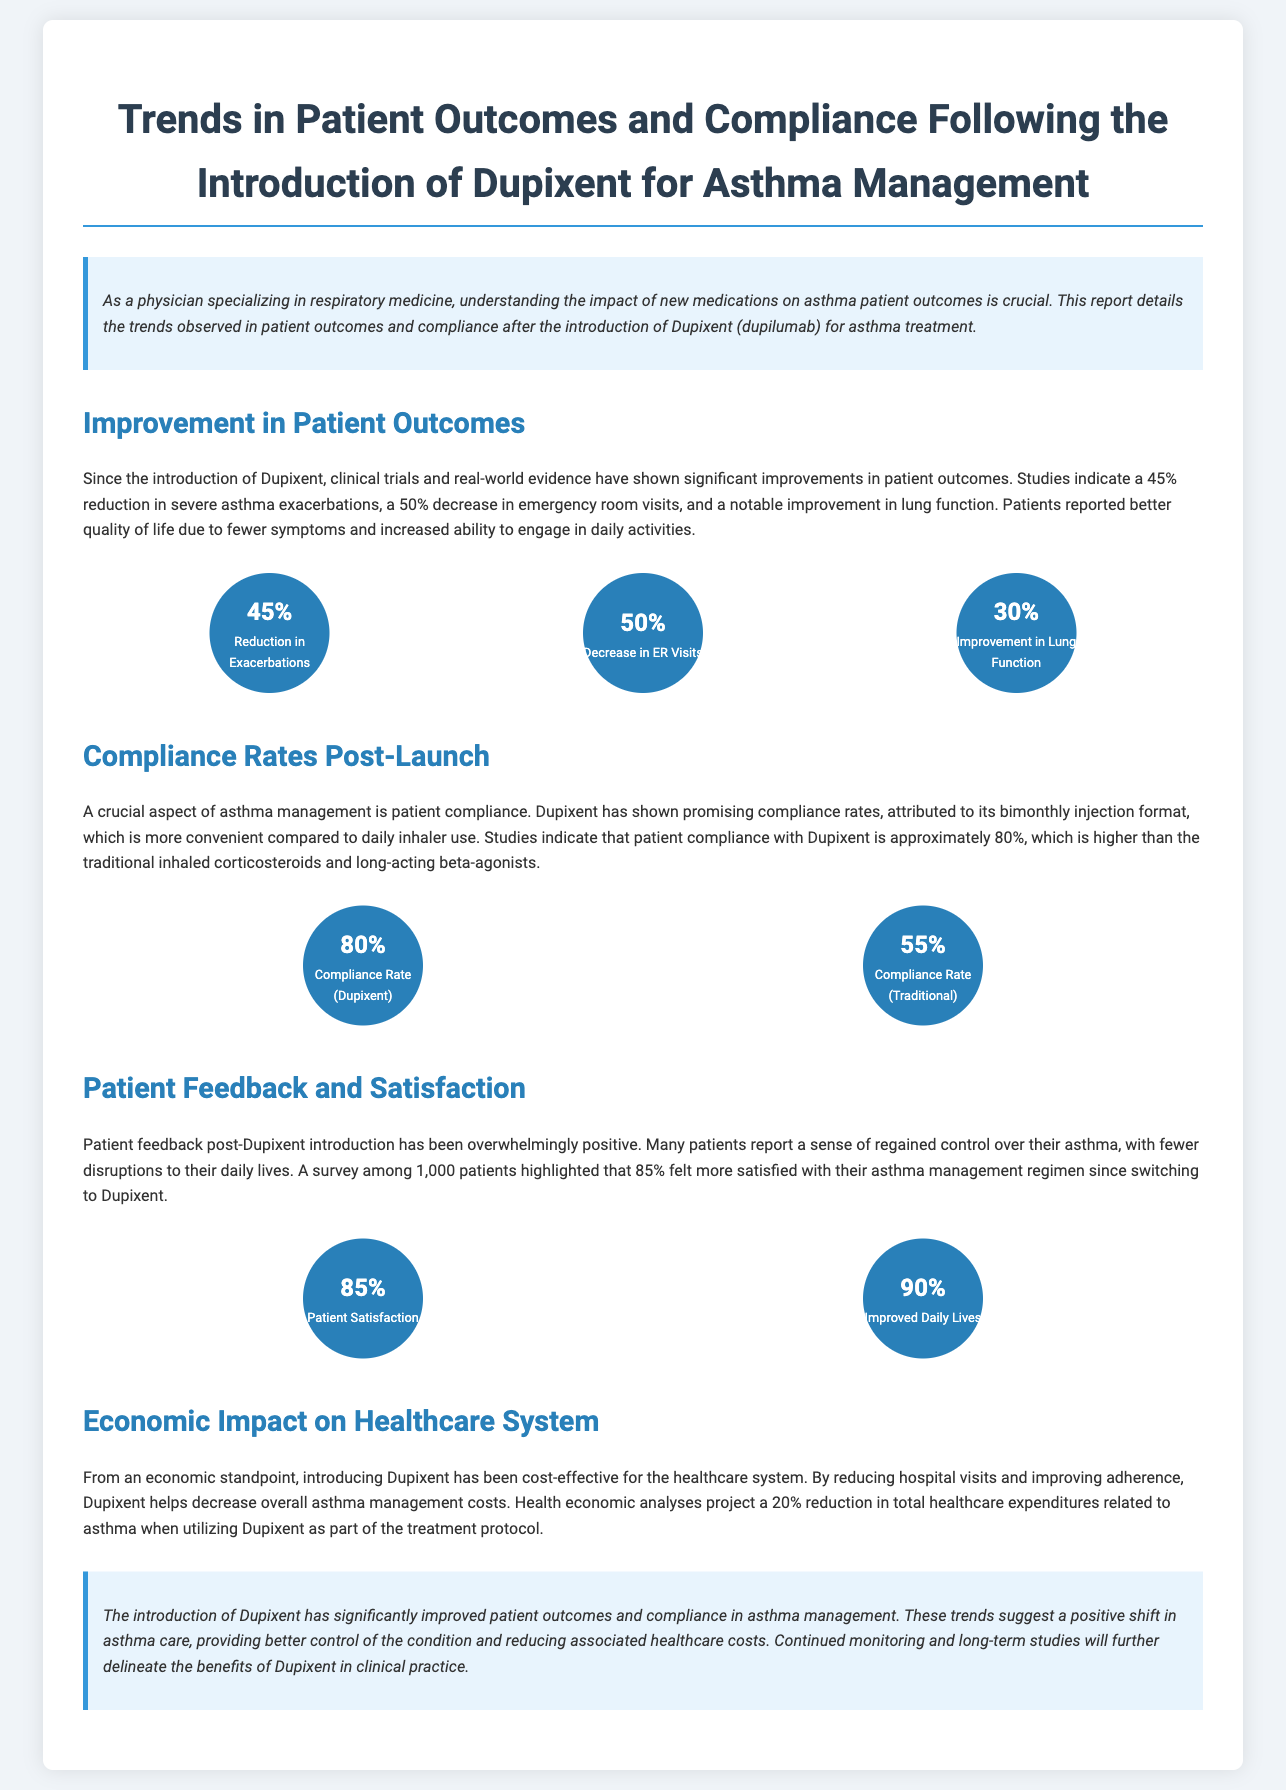What is the reduction in severe asthma exacerbations? The document states that there is a 45% reduction in severe asthma exacerbations observed since the introduction of Dupixent.
Answer: 45% What is the compliance rate for Dupixent? According to the report, patient compliance with Dupixent is approximately 80%, which is mentioned specifically in the section about compliance rates.
Answer: 80% What percentage of patients felt more satisfied with their asthma management after switching to Dupixent? The report reveals that 85% of surveyed patients expressed increased satisfaction with their asthma management regimen since switching to Dupixent.
Answer: 85% What is the decrease in emergency room visits attributed to Dupixent? The report indicates a 50% decrease in emergency room visits following the introduction of Dupixent for asthma management.
Answer: 50% What is the projected reduction in total healthcare expenditures related to asthma with Dupixent? The document mentions a projected 20% reduction in total healthcare expenditures related to asthma when utilizing Dupixent as part of the treatment protocol.
Answer: 20% How many patients reported improvement in their daily lives post-Dupixent? The report states that 90% of patients reported improved daily lives after the introduction of Dupixent.
Answer: 90% 